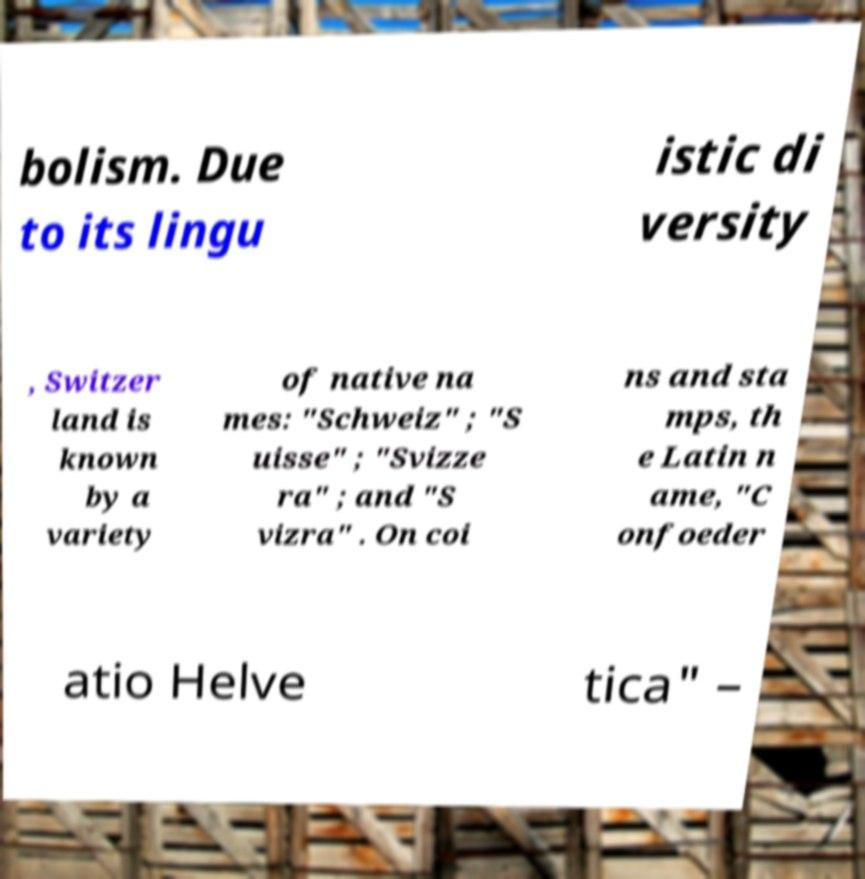Please identify and transcribe the text found in this image. bolism. Due to its lingu istic di versity , Switzer land is known by a variety of native na mes: "Schweiz" ; "S uisse" ; "Svizze ra" ; and "S vizra" . On coi ns and sta mps, th e Latin n ame, "C onfoeder atio Helve tica" – 